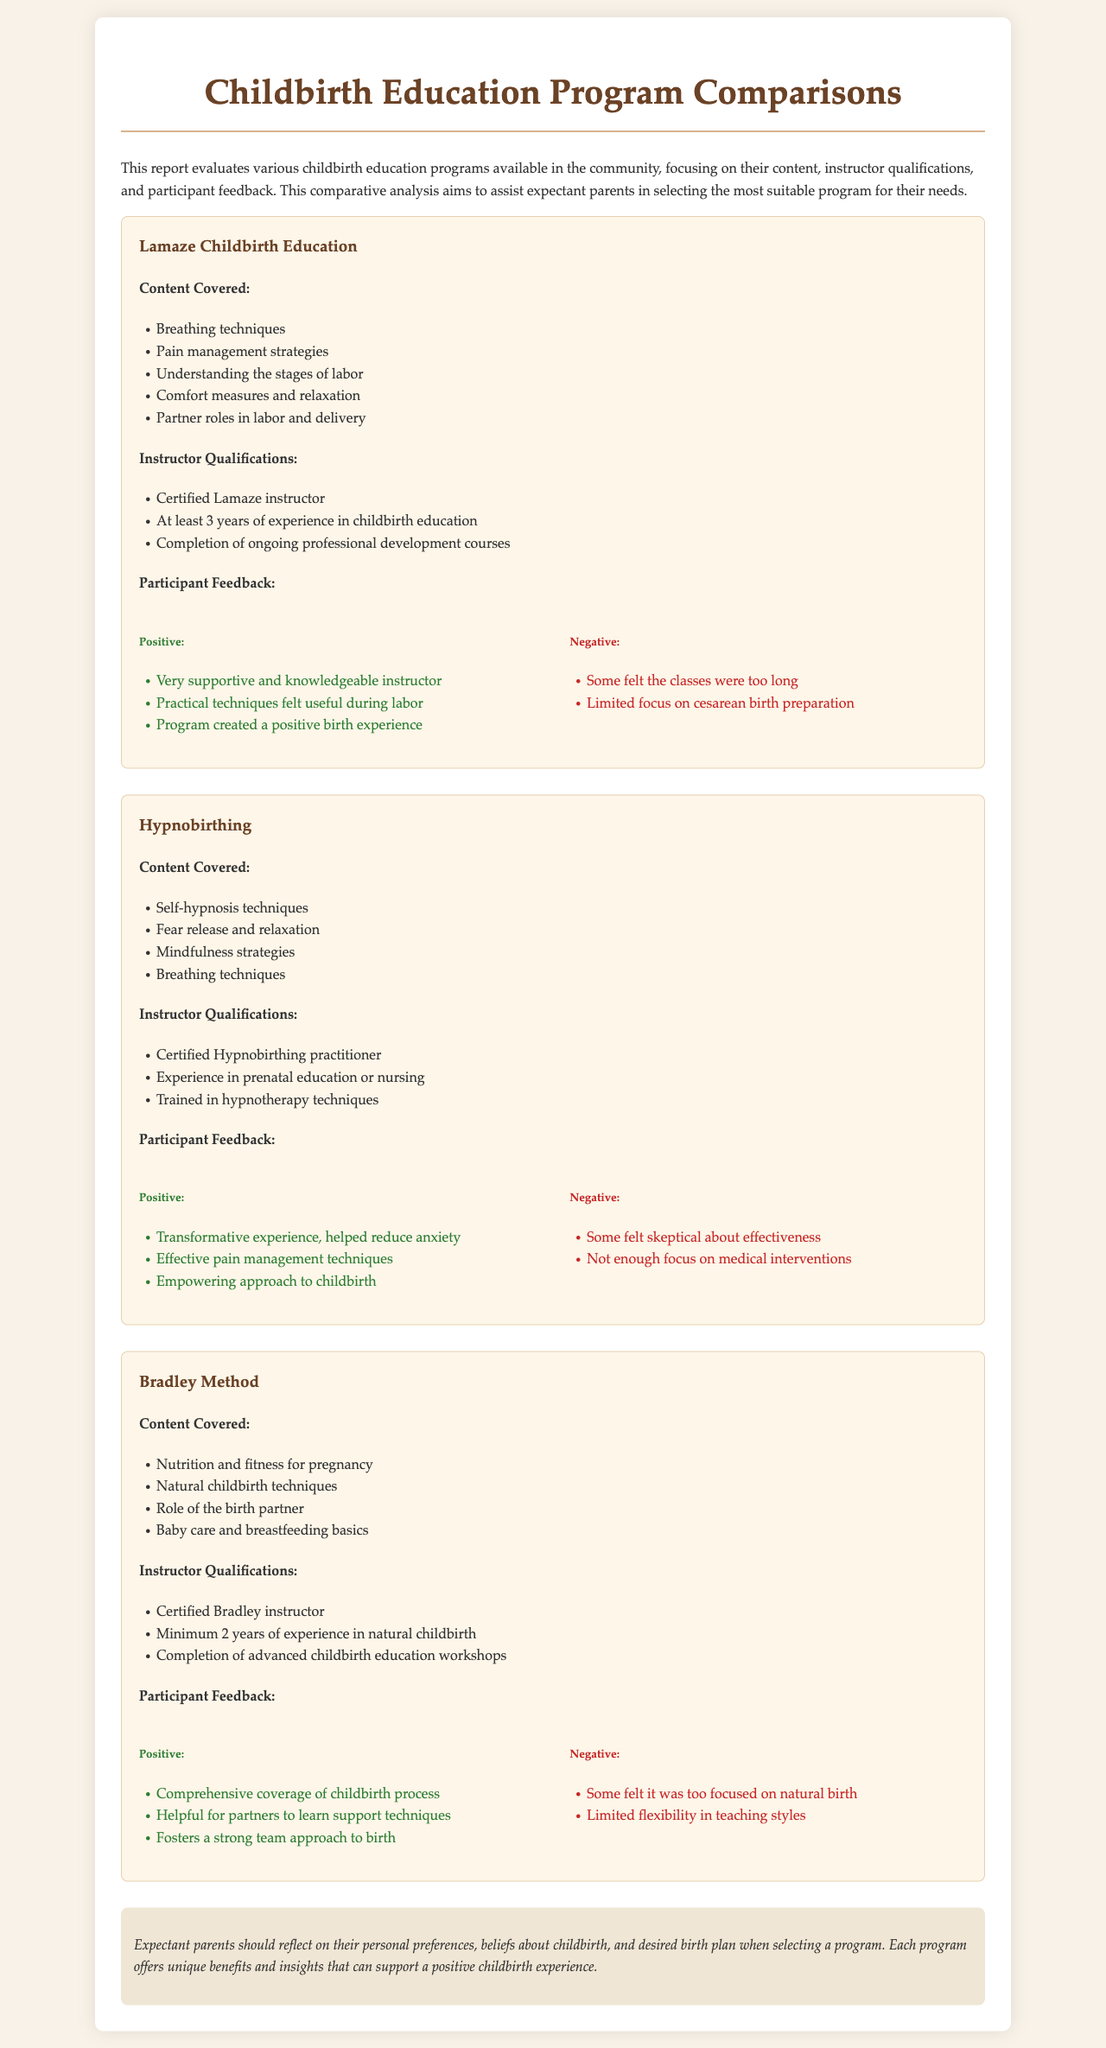What is the title of the report? The title of the report is stated at the top of the document.
Answer: Childbirth Education Program Comparisons How many years of experience does a certified Lamaze instructor need? The document specifies the instructor qualifications for Lamaze childcare education.
Answer: 3 years What program focuses on self-hypnosis techniques? This is a specific detail about the content covered by one of the programs listed.
Answer: Hypnobirthing Which program includes nutrition and fitness for pregnancy in its content? This question requires knowledge of the content covered across the programs mentioned in the report.
Answer: Bradley Method What type of practitioner is required for Hypnobirthing? This is a specific qualification listed under instructor qualifications for one of the programs.
Answer: Certified Hypnobirthing practitioner What common concern was noted by participants of the Bradley Method? This question explores participant feedback regarding the Bradley Method.
Answer: Too focused on natural birth Which program emphasizes the role of partners in childbirth? This question relates to the content covered by different programs and how they engage partners.
Answer: Lamaze Childbirth Education What is one of the positive feedback points for the Hypnobirthing program? This involves reasoning through participant feedback provided in the report.
Answer: Transformative experience, helped reduce anxiety What is the purpose of this report? The purpose is defined in the introductory paragraph of the document.
Answer: Assist expectant parents in selecting the most suitable program 